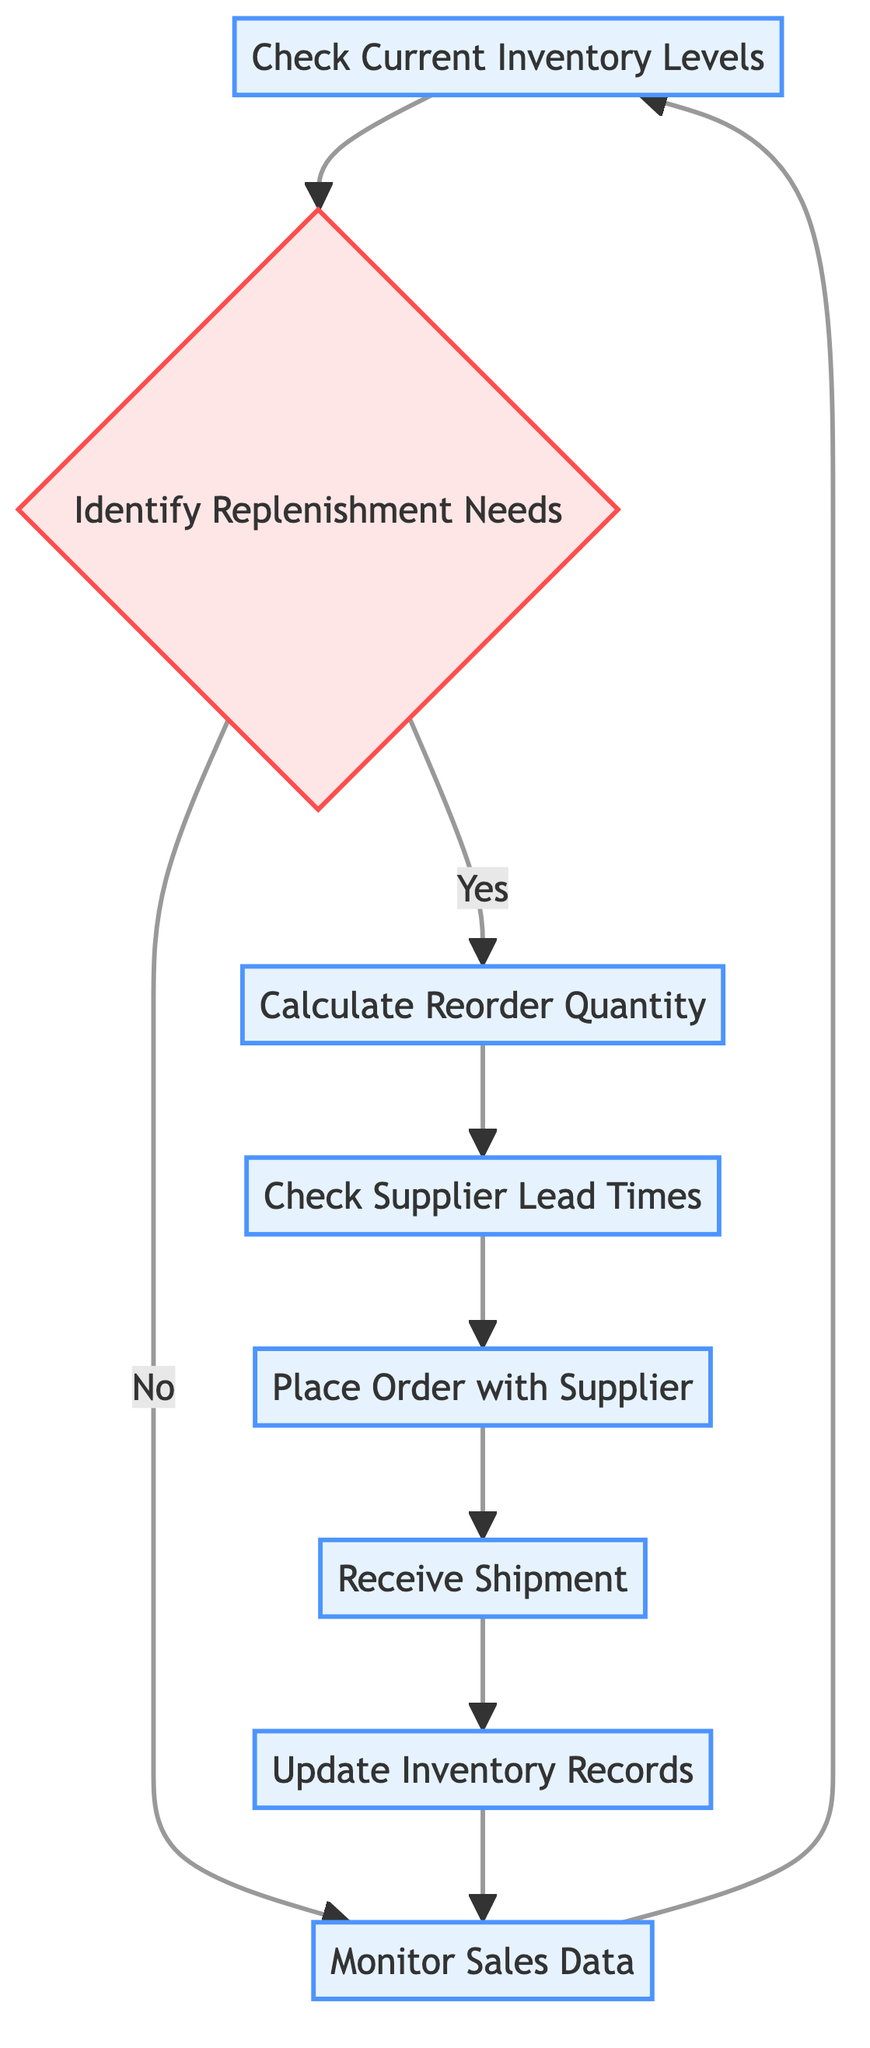What is the first step in the inventory replenishment process? The first step in the process is to "Check Current Inventory Levels," which involves monitoring the current stock of items in the inventory.
Answer: Check Current Inventory Levels How many process nodes are present in the diagram? The diagram contains six process nodes: "Check Current Inventory Levels," "Calculate Reorder Quantity," "Check Supplier Lead Times," "Place Order with Supplier," "Receive Shipment," and "Update Inventory Records."
Answer: Six What action occurs when the answer is "No" to identifying replenishment needs? When the answer is "No," the flow returns to "Monitor Sales Data," which involves continuously keeping track of sales to anticipate future needs.
Answer: Monitor Sales Data What decision needs to be made after checking current inventory levels? After checking current inventory levels, the decision that needs to be made is whether to "Identify Replenishment Needs" based on the current stock levels and sales data.
Answer: Identify Replenishment Needs What is the final step in the inventory stock replenishment process? The final step is "Monitor Sales Data," which is a continuous process that leads back to checking the current inventory levels, creating a loop.
Answer: Monitor Sales Data How many nodes illustrate an ongoing process in the diagram? The diagram illustrates three ongoing processes: "Check Current Inventory Levels," "Monitor Sales Data," and "Update Inventory Records," showing repeated evaluations and adjustments.
Answer: Three What is done after calculating the reorder quantity? After calculating the reorder quantity, the next step is to "Check Supplier Lead Times," which ensures that orders are placed with consideration of how long suppliers take to deliver.
Answer: Check Supplier Lead Times Which node connects to the "Place Order with Supplier" action? The node that connects to the "Place Order with Supplier" action is "Check Supplier Lead Times," indicating that lead time information is essential for making the order.
Answer: Check Supplier Lead Times 